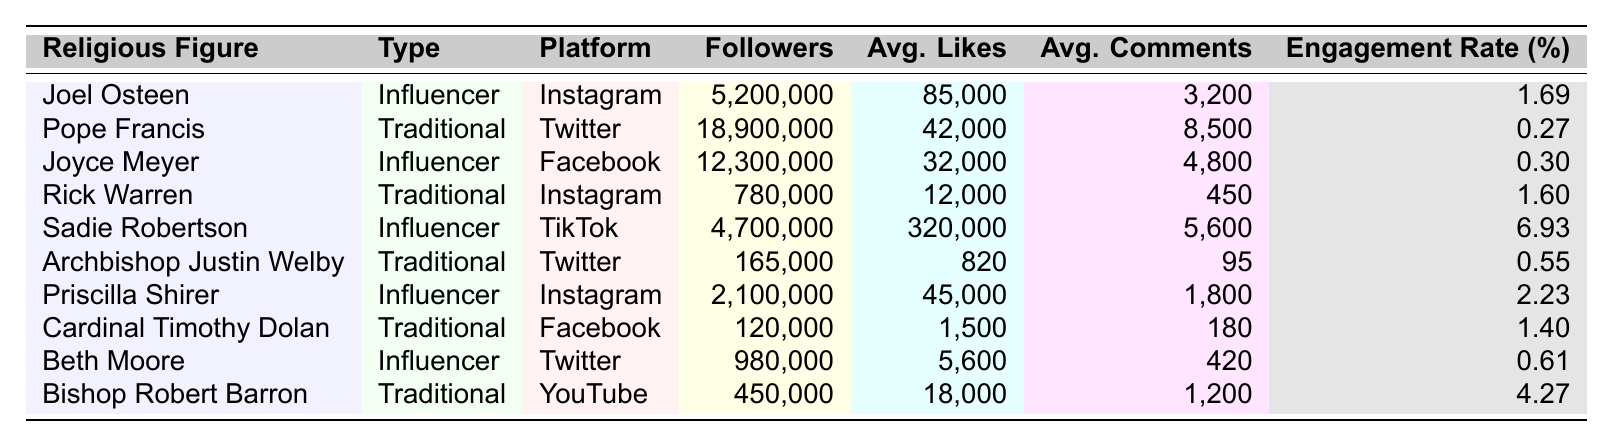What is the engagement rate of Sadie Robertson on TikTok? The table shows Sadie Robertson's engagement rate as 6.93%, which can be directly retrieved from the table.
Answer: 6.93% Who has more followers, Joel Osteen or Joyce Meyer? Joel Osteen has 5,200,000 followers, while Joyce Meyer has 12,300,000 followers. Since 12,300,000 is greater than 5,200,000, Joyce Meyer has more followers.
Answer: Joyce Meyer What is the average engagement rate of traditional religious leaders? The engagement rates for traditional leaders are 0.27%, 1.60%, 0.55%, 1.40%, and 4.27%. Summing these gives 0.27 + 1.60 + 0.55 + 1.40 + 4.27 = 8.09. There are 5 traditional leaders, so the average engagement rate is 8.09 / 5 = 1.618%.
Answer: 1.618% Does any influencer have an engagement rate below 1%? The table shows that the engagement rates for influencers are 1.69%, 0.30%, 6.93%, 2.23%, and 0.61%. Since 0.30% is the only rate that is below 1%, we conclude that yes, there is an influencer with an engagement rate below 1%.
Answer: Yes Which platform has the highest engagement rate, and who is the religious figure associated with it? The table lists individual engagement rates by platform. Sadie Robertson on TikTok has the highest rate at 6.93%, which can be directly retrieved from the table.
Answer: TikTok - Sadie Robertson How much higher is the average likes for Joel Osteen compared to Cardinal Timothy Dolan? Joel Osteen has an average of 85,000 likes and Cardinal Timothy Dolan has 1,500 likes. The difference is 85,000 - 1,500 = 83,500, showing that Joel Osteen's likes are significantly higher.
Answer: 83,500 Which type of religious figure generally has a higher engagement rate, influencers or traditional leaders? By comparing the engagement rates, influencers have rates of 1.69%, 0.30%, 6.93%, 2.23%, and 0.61%; traditional leaders have rates of 0.27%, 1.60%, 0.55%, 1.40%, and 4.27%. The average for influencers is higher (2.015%) compared to traditional leaders (1.618%). Thus, influencers generally have a higher engagement rate.
Answer: Influencers Is Beth Moore the only influencer listed in the table? The table shows five influencers: Joel Osteen, Joyce Meyer, Sadie Robertson, Priscilla Shirer, and Beth Moore, which means Beth Moore is not the only influencer.
Answer: No What is the engagement rate difference between the highest and lowest engagement rates among traditional leaders? The highest engagement rate among traditional leaders is Bishop Robert Barron at 4.27% and the lowest is Pope Francis at 0.27%. The difference is 4.27% - 0.27% = 4.00%.
Answer: 4.00% 